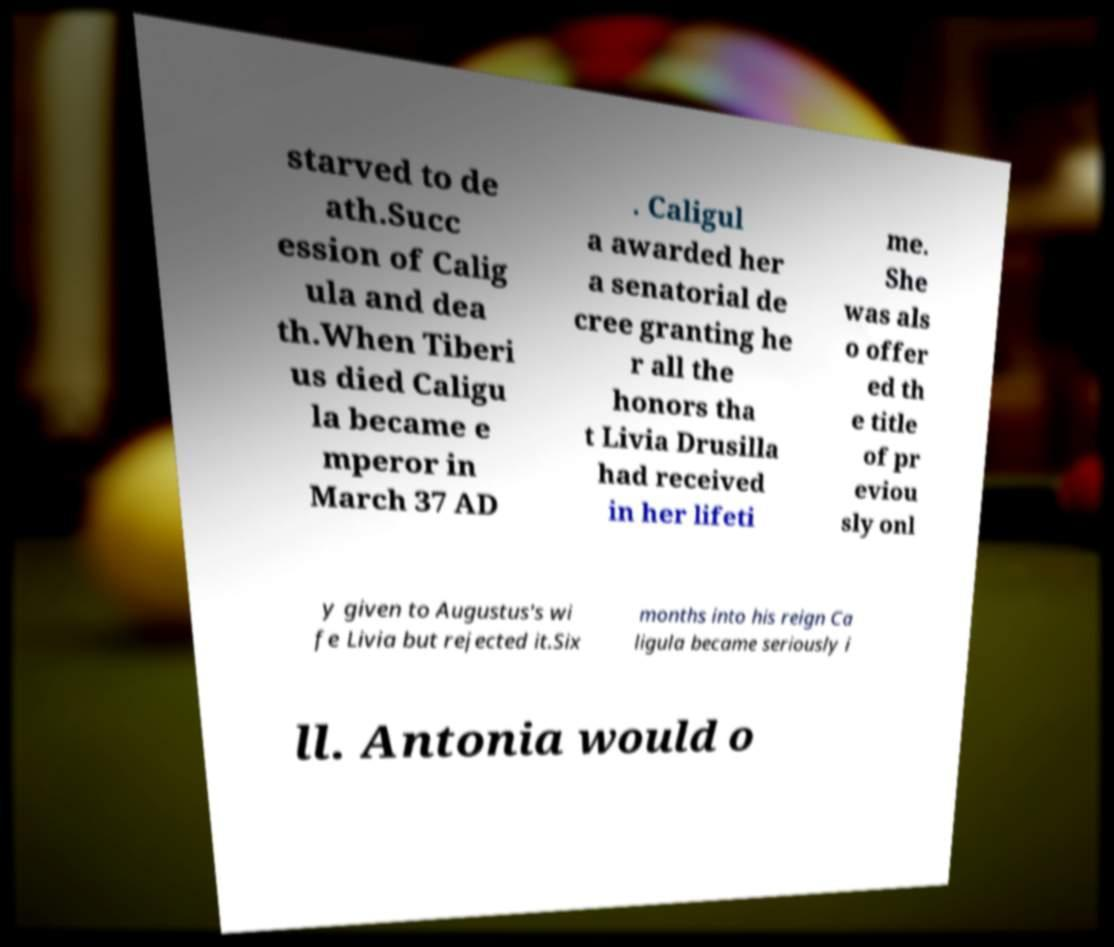What messages or text are displayed in this image? I need them in a readable, typed format. starved to de ath.Succ ession of Calig ula and dea th.When Tiberi us died Caligu la became e mperor in March 37 AD . Caligul a awarded her a senatorial de cree granting he r all the honors tha t Livia Drusilla had received in her lifeti me. She was als o offer ed th e title of pr eviou sly onl y given to Augustus's wi fe Livia but rejected it.Six months into his reign Ca ligula became seriously i ll. Antonia would o 